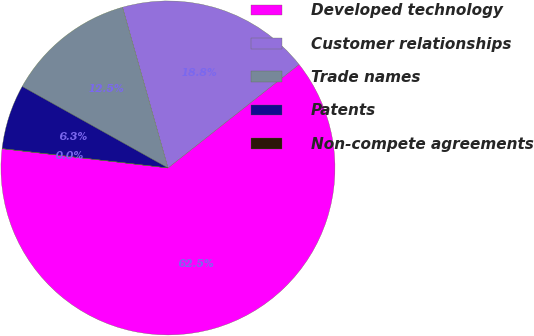<chart> <loc_0><loc_0><loc_500><loc_500><pie_chart><fcel>Developed technology<fcel>Customer relationships<fcel>Trade names<fcel>Patents<fcel>Non-compete agreements<nl><fcel>62.47%<fcel>18.75%<fcel>12.5%<fcel>6.26%<fcel>0.01%<nl></chart> 